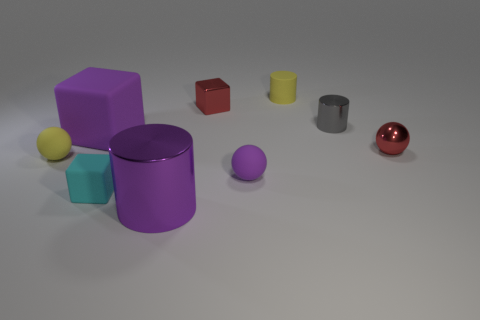How many purple matte cubes are behind the tiny red thing behind the big rubber thing?
Provide a succinct answer. 0. Do the purple object left of the large purple metal cylinder and the block that is to the right of the cyan block have the same size?
Offer a terse response. No. What number of large red rubber cylinders are there?
Your answer should be very brief. 0. What number of cylinders have the same material as the red block?
Offer a very short reply. 2. Are there the same number of tiny rubber spheres in front of the tiny purple ball and tiny yellow rubber cylinders?
Give a very brief answer. No. There is a small cube that is the same color as the shiny ball; what is it made of?
Your answer should be very brief. Metal. There is a red ball; is its size the same as the shiny thing that is in front of the tiny cyan rubber thing?
Provide a succinct answer. No. What number of other objects are there of the same size as the yellow cylinder?
Keep it short and to the point. 6. How many other objects are the same color as the matte cylinder?
Provide a short and direct response. 1. Are there any other things that are the same size as the metallic block?
Provide a succinct answer. Yes. 